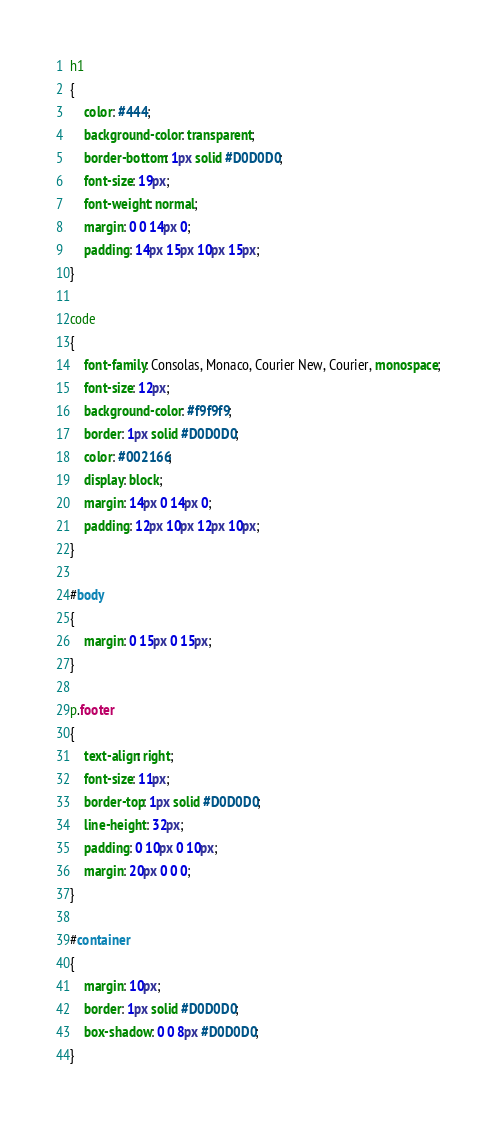<code> <loc_0><loc_0><loc_500><loc_500><_CSS_>h1 
{
	color: #444;
	background-color: transparent;
	border-bottom: 1px solid #D0D0D0;
	font-size: 19px;
	font-weight: normal;
	margin: 0 0 14px 0;
	padding: 14px 15px 10px 15px;
}

code 
{
	font-family: Consolas, Monaco, Courier New, Courier, monospace;
	font-size: 12px;
	background-color: #f9f9f9;
	border: 1px solid #D0D0D0;
	color: #002166;
	display: block;
	margin: 14px 0 14px 0;
	padding: 12px 10px 12px 10px;
}

#body 
{
	margin: 0 15px 0 15px;
}

p.footer 
{
	text-align: right;
	font-size: 11px;
	border-top: 1px solid #D0D0D0;
	line-height: 32px;
	padding: 0 10px 0 10px;
	margin: 20px 0 0 0;
}

#container 
{
	margin: 10px;
	border: 1px solid #D0D0D0;
	box-shadow: 0 0 8px #D0D0D0;
}</code> 